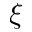Convert formula to latex. <formula><loc_0><loc_0><loc_500><loc_500>\xi</formula> 